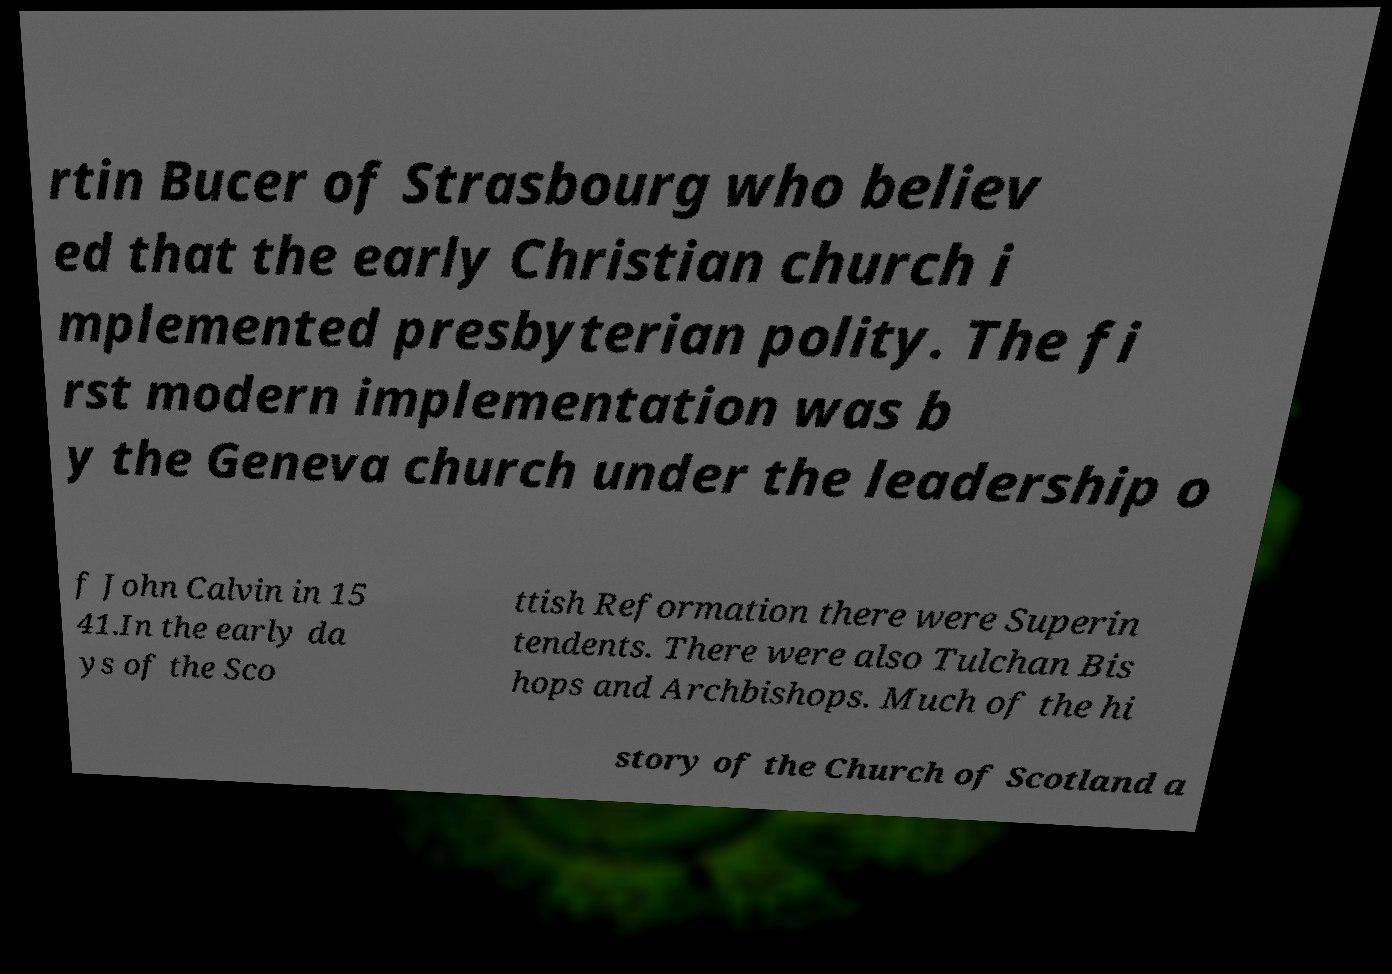I need the written content from this picture converted into text. Can you do that? rtin Bucer of Strasbourg who believ ed that the early Christian church i mplemented presbyterian polity. The fi rst modern implementation was b y the Geneva church under the leadership o f John Calvin in 15 41.In the early da ys of the Sco ttish Reformation there were Superin tendents. There were also Tulchan Bis hops and Archbishops. Much of the hi story of the Church of Scotland a 